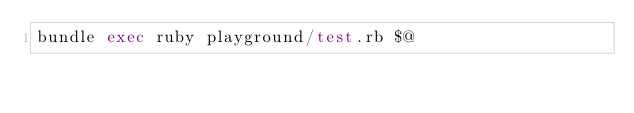<code> <loc_0><loc_0><loc_500><loc_500><_Bash_>bundle exec ruby playground/test.rb $@
</code> 